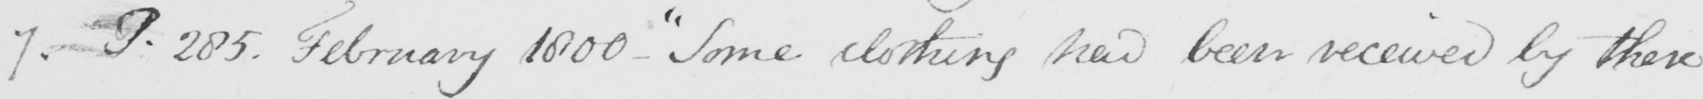What is written in this line of handwriting? 7 . P.285 . February 1800 _   " Some clothing had been received by these 